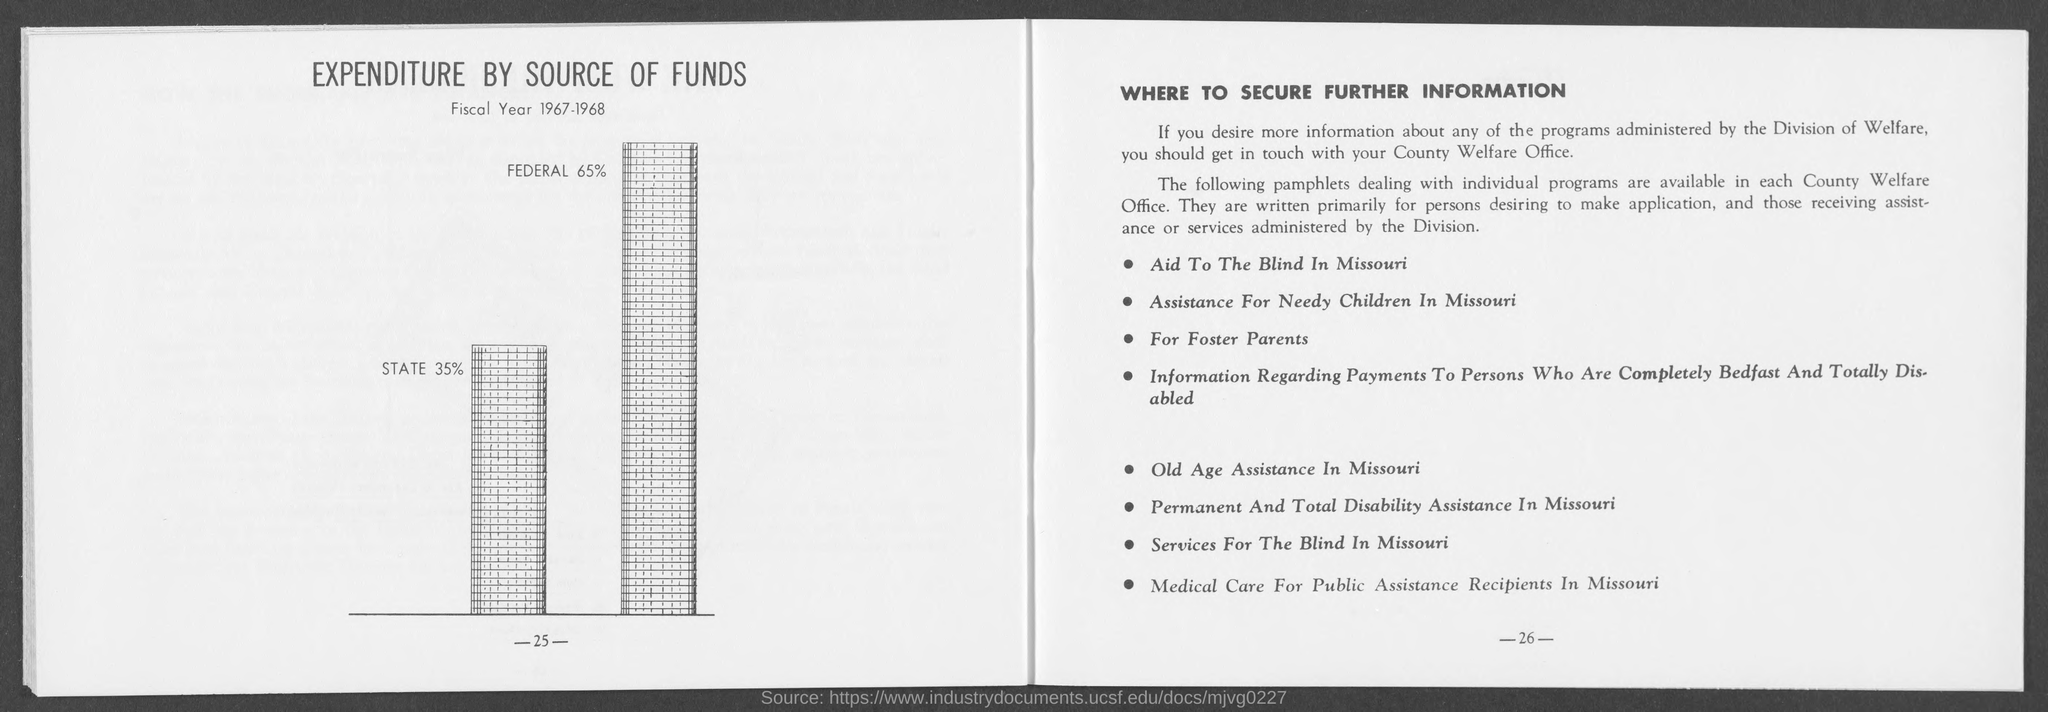What is the percentage of federal as mentioned in the given page ?
Ensure brevity in your answer.  65%. What is the percentage of state as mentioned in the given page ?
Offer a very short reply. 35. 